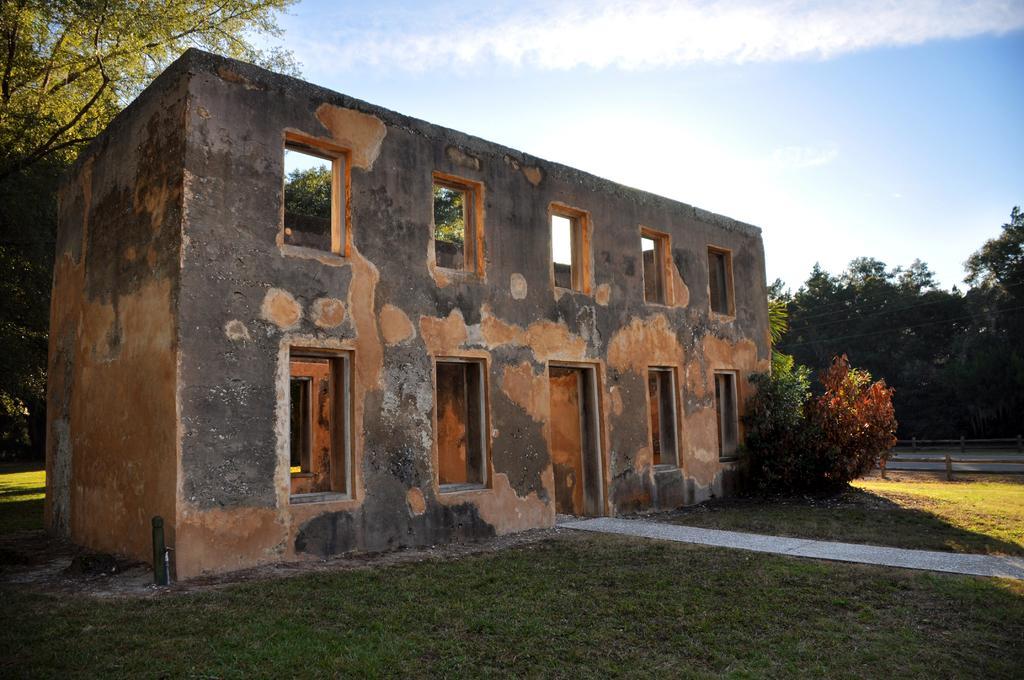Please provide a concise description of this image. In this image I can see in the middle it is an old construction. On the left side there are trees, at the top it is the sky. 